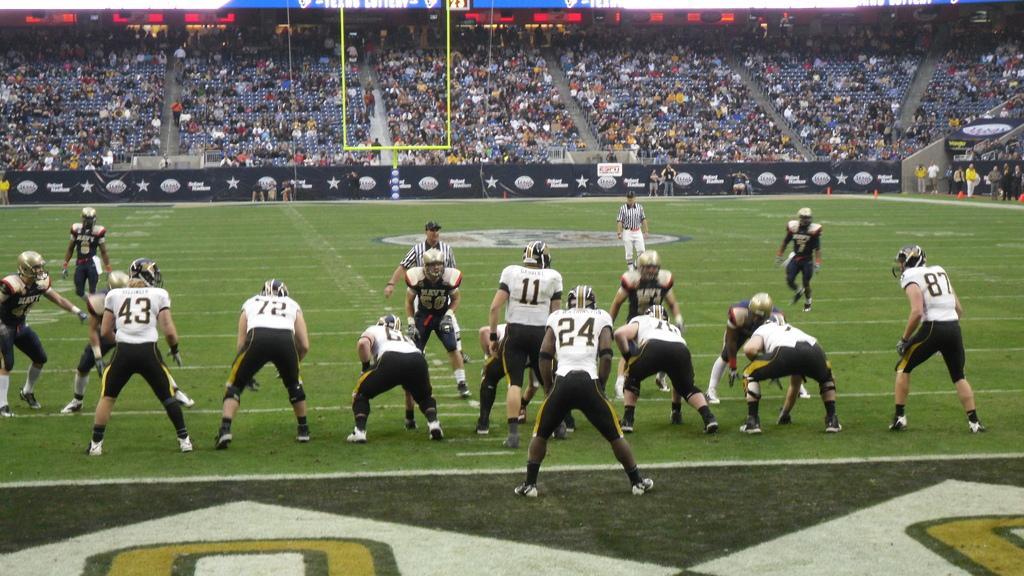How would you summarize this image in a sentence or two? This is the picture of a stadium. In this picture there are group of people standing in the foreground. At the back there are group of people sitting. At the bottom there are hoardings and there is grass. 